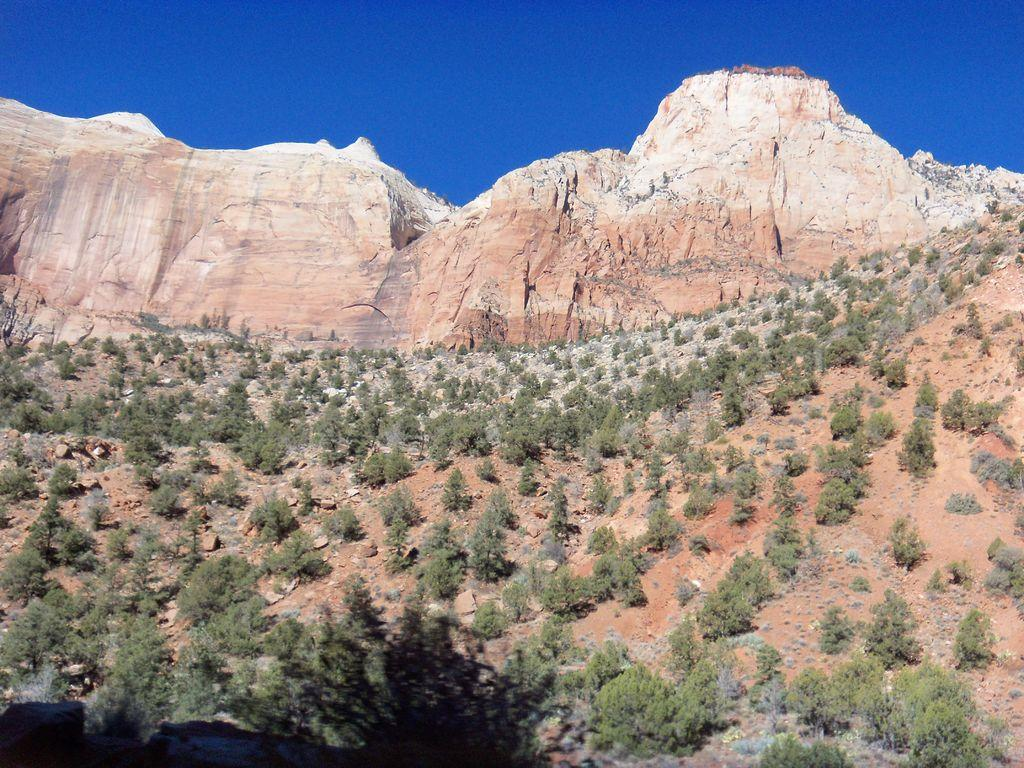What type of natural formation can be seen in the image? There are mountains in the image. What other elements are present in the image besides the mountains? There are plants and stones visible in the image. What part of the natural environment is visible in the image? The sky is visible in the image. What type of wine is being served in the image? There is no wine present in the image; it features mountains, plants, stones, and the sky. 